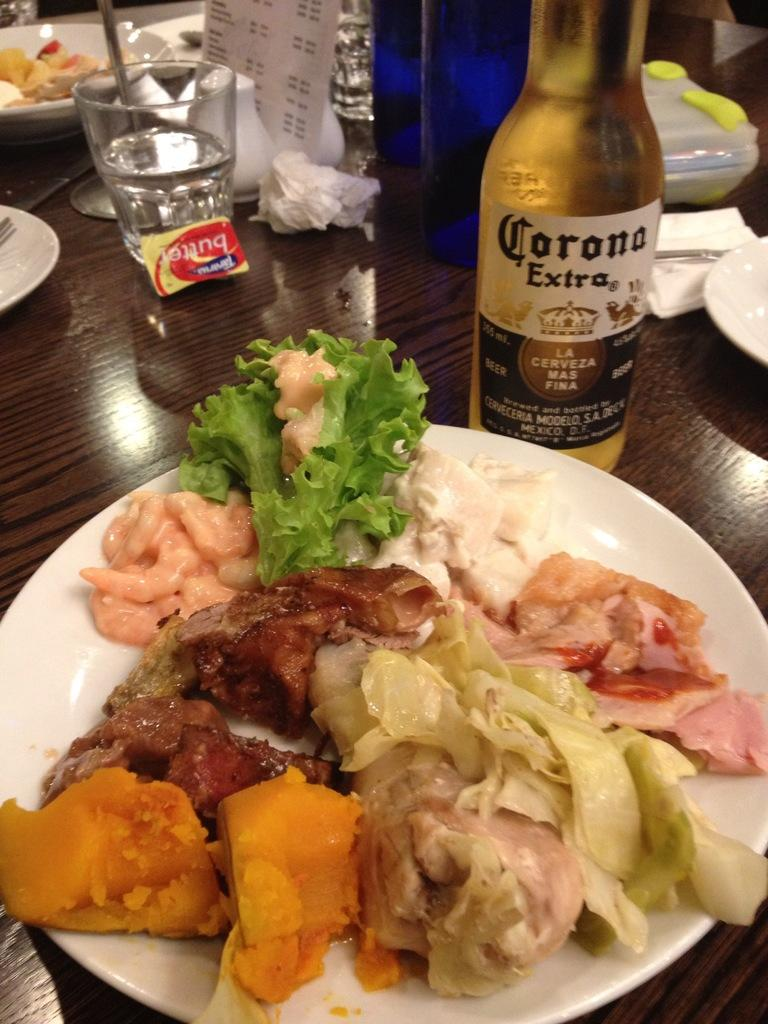<image>
Offer a succinct explanation of the picture presented. A plate of food in front of a cold bottle of Corona Extra beer. 